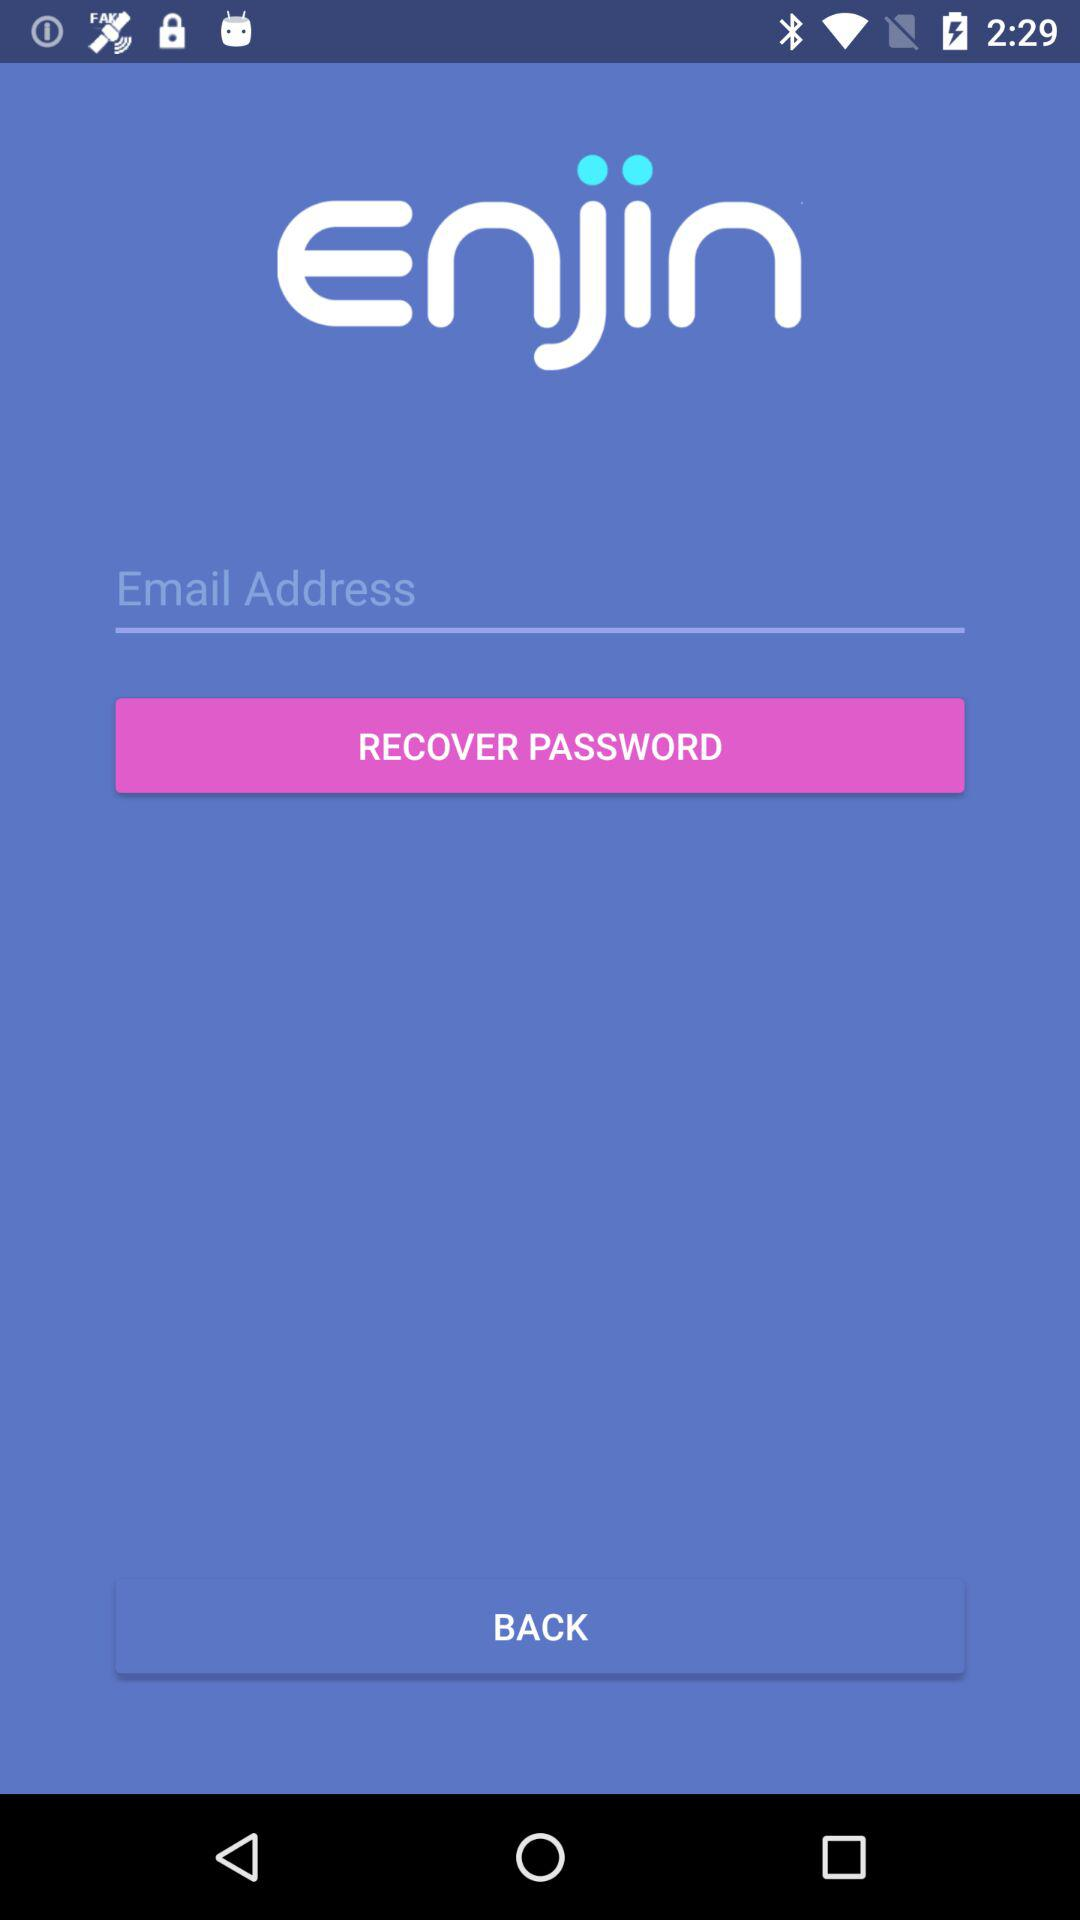What is the contact number? The contact number is (866) 246-2400. 